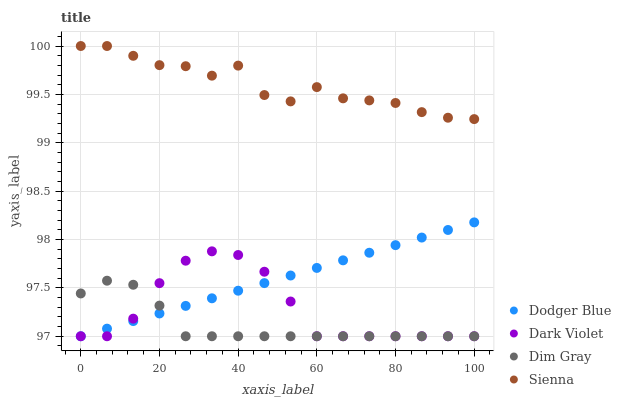Does Dim Gray have the minimum area under the curve?
Answer yes or no. Yes. Does Sienna have the maximum area under the curve?
Answer yes or no. Yes. Does Dodger Blue have the minimum area under the curve?
Answer yes or no. No. Does Dodger Blue have the maximum area under the curve?
Answer yes or no. No. Is Dodger Blue the smoothest?
Answer yes or no. Yes. Is Sienna the roughest?
Answer yes or no. Yes. Is Dim Gray the smoothest?
Answer yes or no. No. Is Dim Gray the roughest?
Answer yes or no. No. Does Dim Gray have the lowest value?
Answer yes or no. Yes. Does Sienna have the highest value?
Answer yes or no. Yes. Does Dodger Blue have the highest value?
Answer yes or no. No. Is Dim Gray less than Sienna?
Answer yes or no. Yes. Is Sienna greater than Dark Violet?
Answer yes or no. Yes. Does Dodger Blue intersect Dark Violet?
Answer yes or no. Yes. Is Dodger Blue less than Dark Violet?
Answer yes or no. No. Is Dodger Blue greater than Dark Violet?
Answer yes or no. No. Does Dim Gray intersect Sienna?
Answer yes or no. No. 